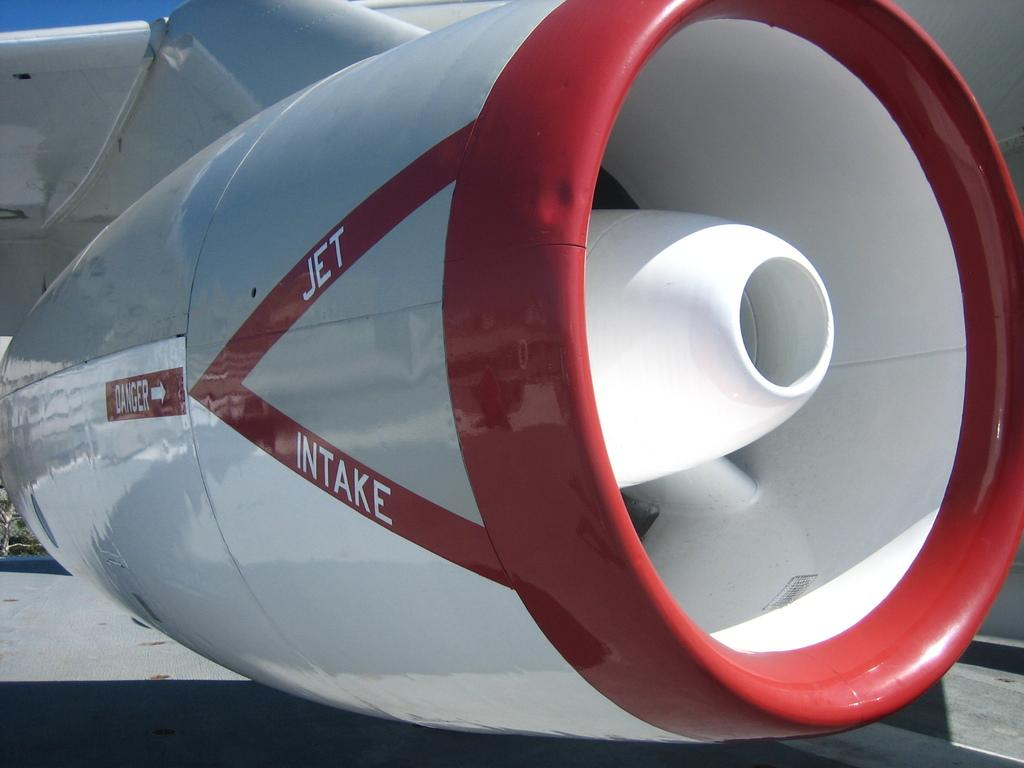<image>
Give a short and clear explanation of the subsequent image. The engine of an airplane has the words jet and intake on it. 